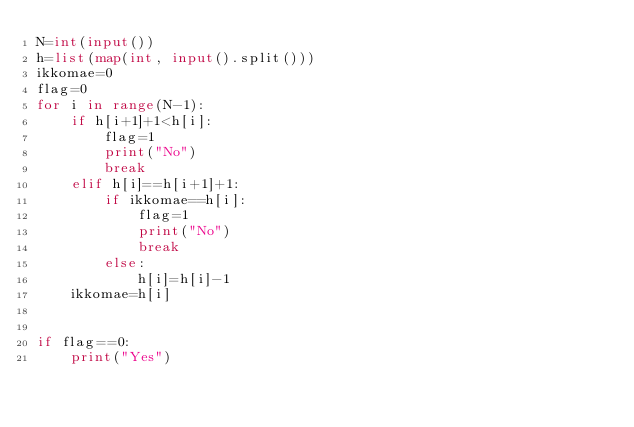Convert code to text. <code><loc_0><loc_0><loc_500><loc_500><_Python_>N=int(input())
h=list(map(int, input().split()))
ikkomae=0
flag=0
for i in range(N-1):
    if h[i+1]+1<h[i]:
        flag=1
        print("No")
        break
    elif h[i]==h[i+1]+1:
        if ikkomae==h[i]:
            flag=1
            print("No")
            break
        else:
            h[i]=h[i]-1
    ikkomae=h[i]


if flag==0:
    print("Yes")   
     </code> 